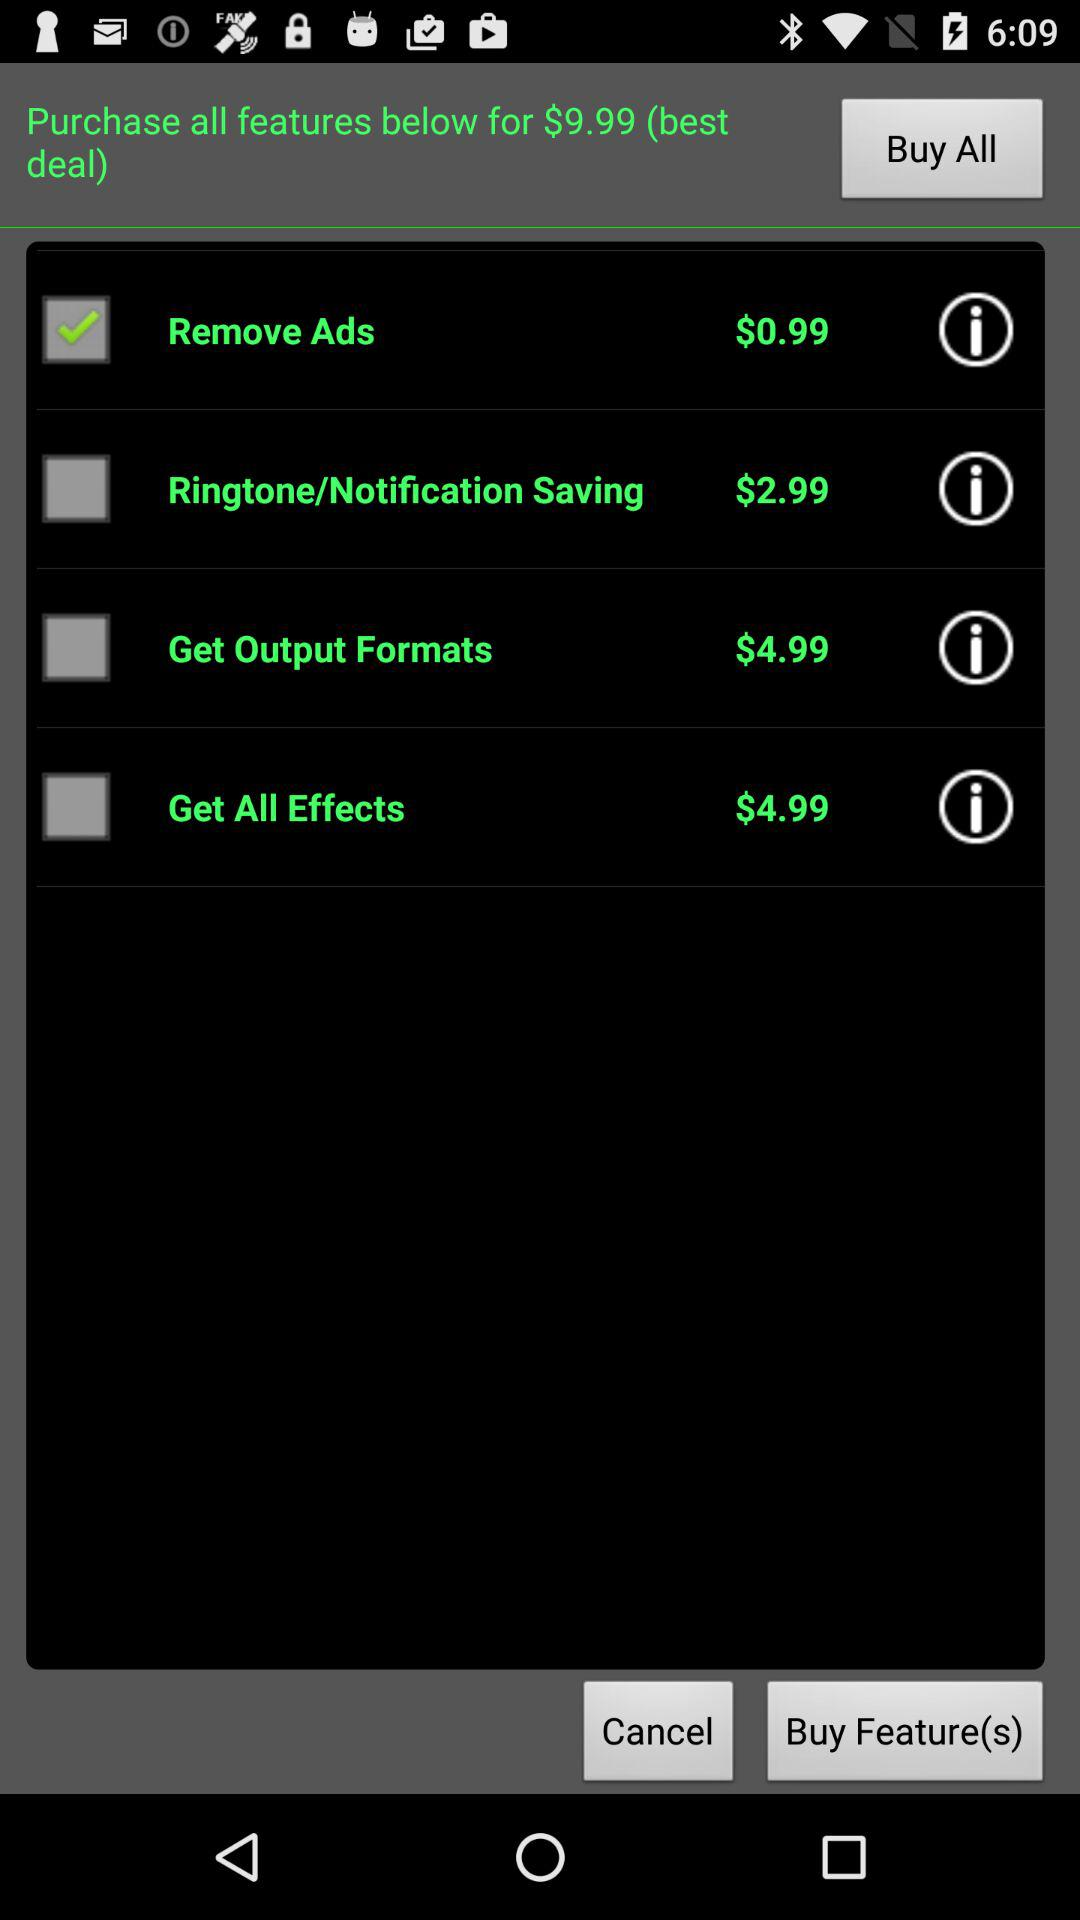What is the purchase price of "Get Output Formats"? The price is $4.99. 